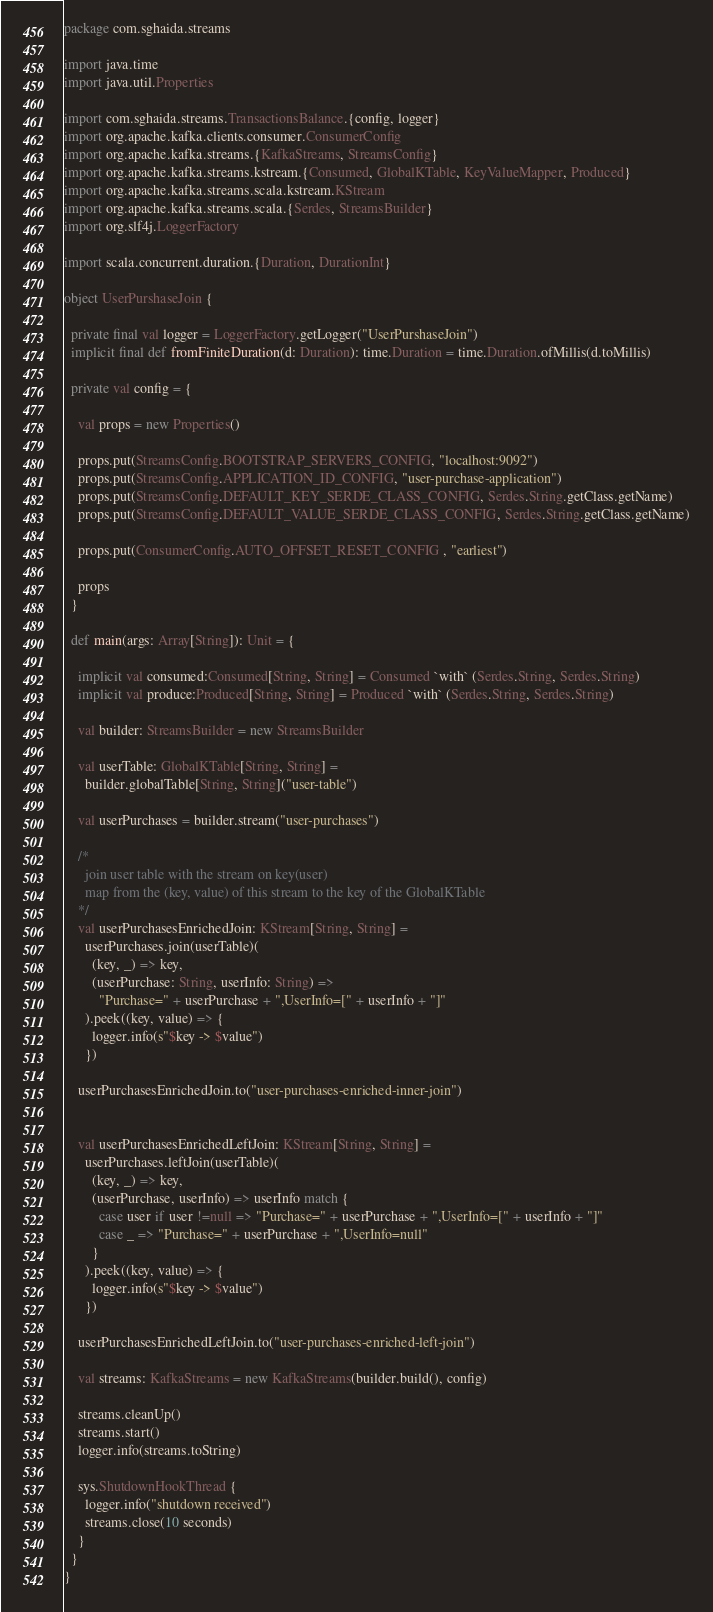<code> <loc_0><loc_0><loc_500><loc_500><_Scala_>package com.sghaida.streams

import java.time
import java.util.Properties

import com.sghaida.streams.TransactionsBalance.{config, logger}
import org.apache.kafka.clients.consumer.ConsumerConfig
import org.apache.kafka.streams.{KafkaStreams, StreamsConfig}
import org.apache.kafka.streams.kstream.{Consumed, GlobalKTable, KeyValueMapper, Produced}
import org.apache.kafka.streams.scala.kstream.KStream
import org.apache.kafka.streams.scala.{Serdes, StreamsBuilder}
import org.slf4j.LoggerFactory

import scala.concurrent.duration.{Duration, DurationInt}

object UserPurshaseJoin {

  private final val logger = LoggerFactory.getLogger("UserPurshaseJoin")
  implicit final def fromFiniteDuration(d: Duration): time.Duration = time.Duration.ofMillis(d.toMillis)

  private val config = {

    val props = new Properties()

    props.put(StreamsConfig.BOOTSTRAP_SERVERS_CONFIG, "localhost:9092")
    props.put(StreamsConfig.APPLICATION_ID_CONFIG, "user-purchase-application")
    props.put(StreamsConfig.DEFAULT_KEY_SERDE_CLASS_CONFIG, Serdes.String.getClass.getName)
    props.put(StreamsConfig.DEFAULT_VALUE_SERDE_CLASS_CONFIG, Serdes.String.getClass.getName)

    props.put(ConsumerConfig.AUTO_OFFSET_RESET_CONFIG , "earliest")

    props
  }

  def main(args: Array[String]): Unit = {

    implicit val consumed:Consumed[String, String] = Consumed `with` (Serdes.String, Serdes.String)
    implicit val produce:Produced[String, String] = Produced `with` (Serdes.String, Serdes.String)

    val builder: StreamsBuilder = new StreamsBuilder

    val userTable: GlobalKTable[String, String] =
      builder.globalTable[String, String]("user-table")

    val userPurchases = builder.stream("user-purchases")

    /*
      join user table with the stream on key(user)
      map from the (key, value) of this stream to the key of the GlobalKTable
    */
    val userPurchasesEnrichedJoin: KStream[String, String] =
      userPurchases.join(userTable)(
        (key, _) => key,
        (userPurchase: String, userInfo: String) =>
          "Purchase=" + userPurchase + ",UserInfo=[" + userInfo + "]"
      ).peek((key, value) => {
        logger.info(s"$key -> $value")
      })

    userPurchasesEnrichedJoin.to("user-purchases-enriched-inner-join")


    val userPurchasesEnrichedLeftJoin: KStream[String, String] =
      userPurchases.leftJoin(userTable)(
        (key, _) => key,
        (userPurchase, userInfo) => userInfo match {
          case user if user !=null => "Purchase=" + userPurchase + ",UserInfo=[" + userInfo + "]"
          case _ => "Purchase=" + userPurchase + ",UserInfo=null"
        }
      ).peek((key, value) => {
        logger.info(s"$key -> $value")
      })

    userPurchasesEnrichedLeftJoin.to("user-purchases-enriched-left-join")

    val streams: KafkaStreams = new KafkaStreams(builder.build(), config)

    streams.cleanUp()
    streams.start()
    logger.info(streams.toString)

    sys.ShutdownHookThread {
      logger.info("shutdown received")
      streams.close(10 seconds)
    }
  }
}
</code> 